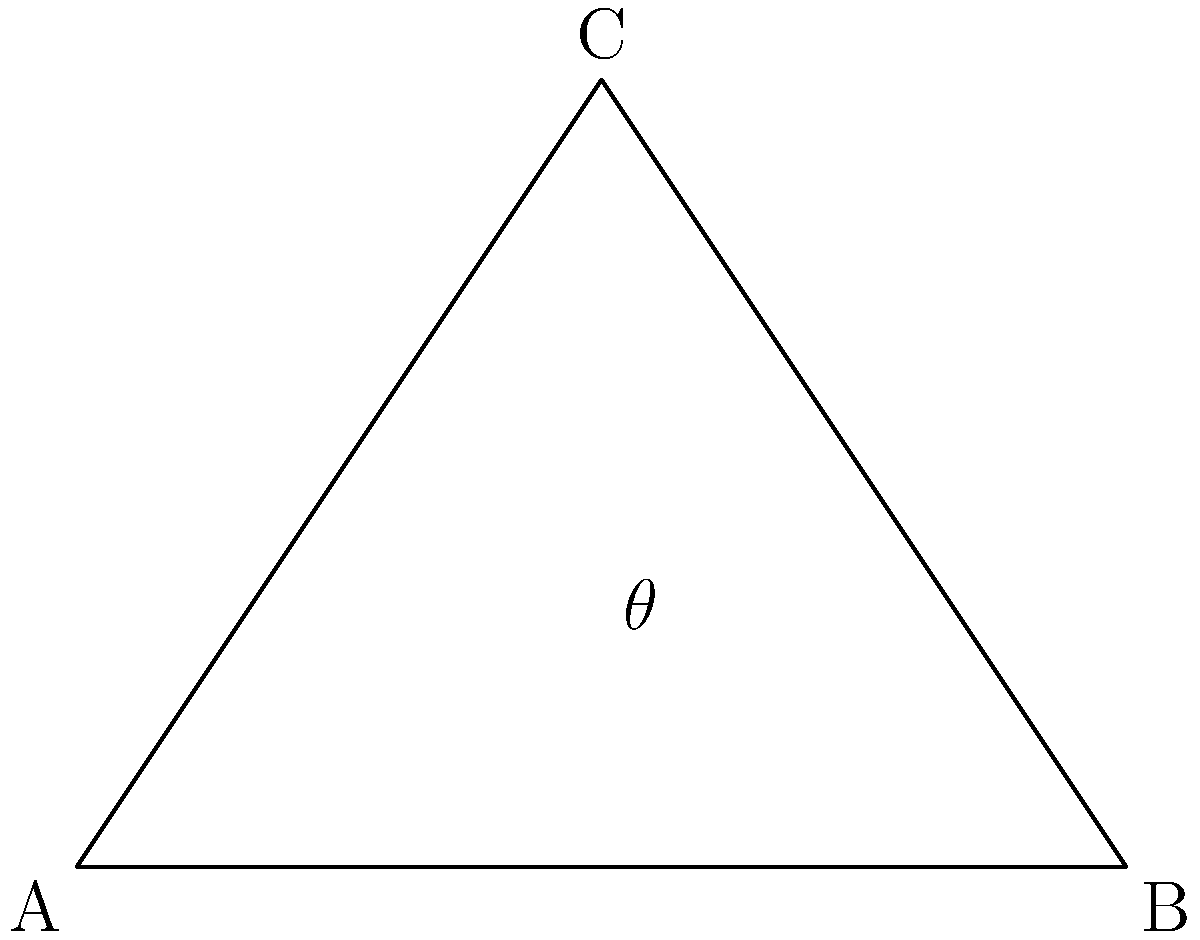You're designing a unique dress pattern and need to determine the angle between two intersecting seam lines. The pattern piece is represented by triangle ABC, where AB is the bottom edge, and AC and BC are the seam lines. If the coordinates of the points are A(0,0), B(4,0), and C(2,3), calculate the angle $\theta$ between the seam lines AC and BC. To find the angle between two lines, we can use the dot product formula:

$$\cos \theta = \frac{\vec{u} \cdot \vec{v}}{|\vec{u}||\vec{v}|}$$

Where $\vec{u}$ and $\vec{v}$ are vectors representing the seam lines.

Step 1: Find vectors $\vec{AC}$ and $\vec{BC}$
$\vec{AC} = (2-0, 3-0) = (2,3)$
$\vec{BC} = (2-4, 3-0) = (-2,3)$

Step 2: Calculate the dot product $\vec{AC} \cdot \vec{BC}$
$\vec{AC} \cdot \vec{BC} = (2)(-2) + (3)(3) = -4 + 9 = 5$

Step 3: Calculate the magnitudes $|\vec{AC}|$ and $|\vec{BC}|$
$|\vec{AC}| = \sqrt{2^2 + 3^2} = \sqrt{13}$
$|\vec{BC}| = \sqrt{(-2)^2 + 3^2} = \sqrt{13}$

Step 4: Apply the dot product formula
$$\cos \theta = \frac{5}{\sqrt{13} \cdot \sqrt{13}} = \frac{5}{13}$$

Step 5: Solve for $\theta$
$$\theta = \arccos(\frac{5}{13})$$

Step 6: Convert to degrees
$$\theta \approx 67.38^\circ$$
Answer: $67.38^\circ$ 